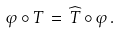<formula> <loc_0><loc_0><loc_500><loc_500>\varphi \circ T \, = \, \widehat { T } \circ \varphi \, .</formula> 